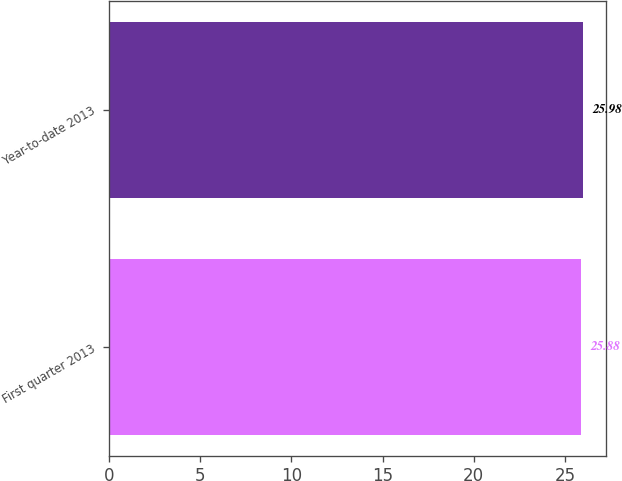Convert chart to OTSL. <chart><loc_0><loc_0><loc_500><loc_500><bar_chart><fcel>First quarter 2013<fcel>Year-to-date 2013<nl><fcel>25.88<fcel>25.98<nl></chart> 